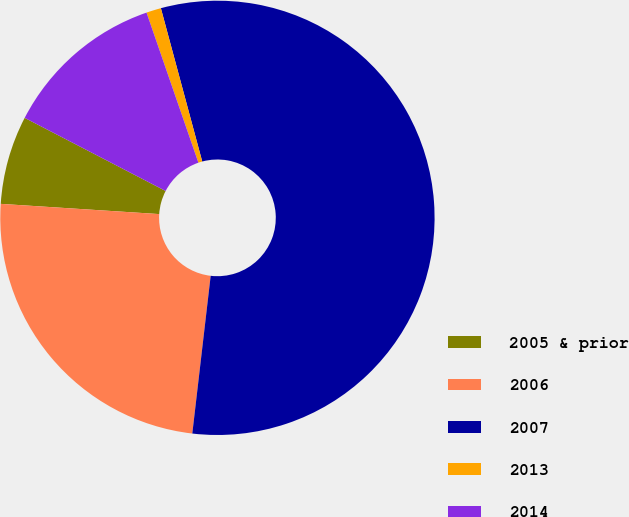Convert chart. <chart><loc_0><loc_0><loc_500><loc_500><pie_chart><fcel>2005 & prior<fcel>2006<fcel>2007<fcel>2013<fcel>2014<nl><fcel>6.59%<fcel>24.18%<fcel>56.04%<fcel>1.1%<fcel>12.09%<nl></chart> 